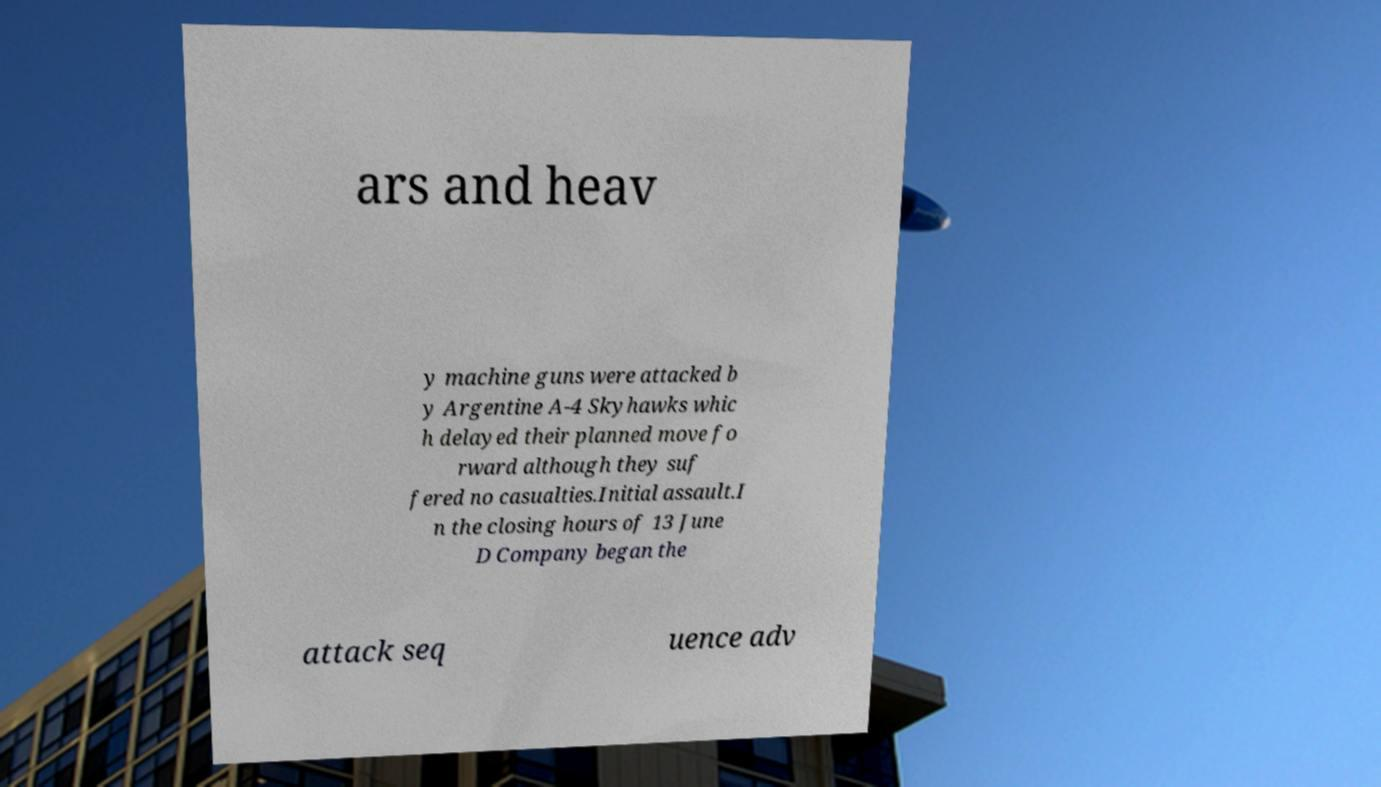Can you accurately transcribe the text from the provided image for me? ars and heav y machine guns were attacked b y Argentine A-4 Skyhawks whic h delayed their planned move fo rward although they suf fered no casualties.Initial assault.I n the closing hours of 13 June D Company began the attack seq uence adv 